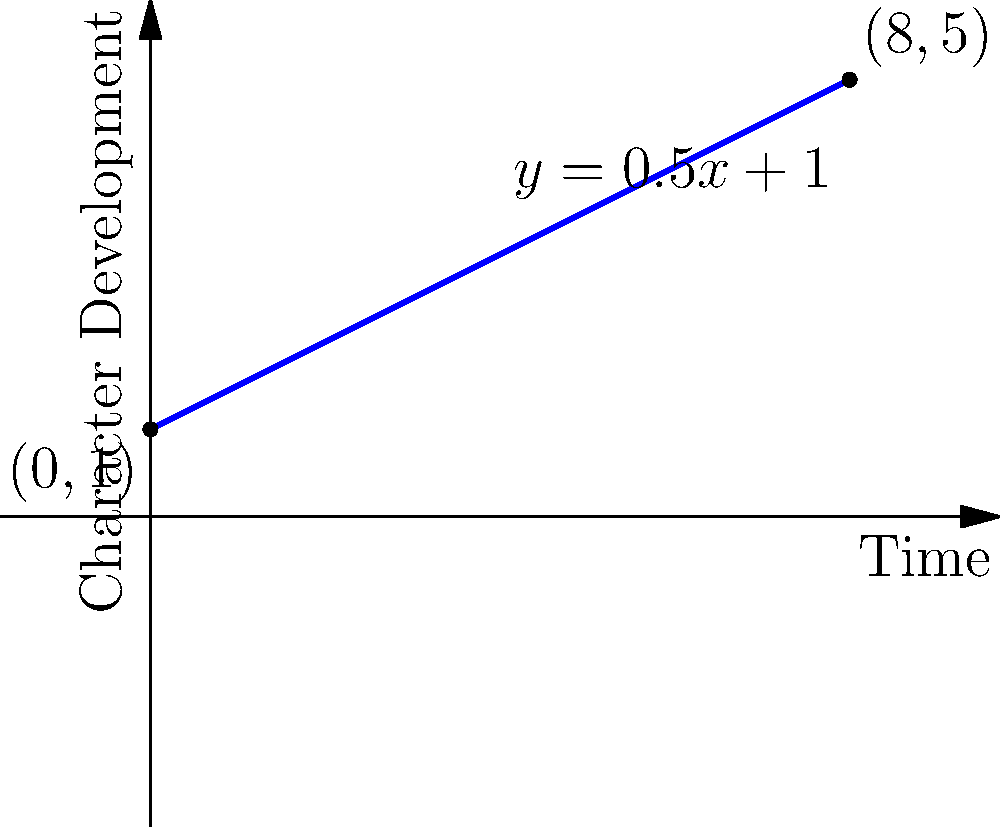In creative writing, character development can be visualized using the slope-intercept form of a line. Consider the graph above representing a character's growth over time in a narrative. The line is described by the equation $y = 0.5x + 1$, where $x$ represents time and $y$ represents the level of character development. What does the slope (0.5) indicate about the character's progression, and how might this inform the pacing of the narrative? To analyze the character development trajectory using the slope-intercept form:

1. Identify the equation: $y = 0.5x + 1$

2. Break down the components:
   - Slope (m) = 0.5
   - y-intercept (b) = 1

3. Interpret the slope (0.5):
   - The slope represents the rate of change in character development over time.
   - A positive slope indicates growth or positive development.
   - The value 0.5 suggests a moderate, steady rate of growth.

4. Analyze the y-intercept (1):
   - This represents the character's initial development level at the start of the narrative.

5. Consider the implications for narrative pacing:
   - The moderate slope implies a gradual, consistent character arc.
   - This suggests a narrative that allows for steady character growth rather than sudden transformations.
   - The pacing should reflect this gradual development, potentially focusing on small, incremental changes in the character over time.

6. Evaluate the end point (8,5):
   - After 8 units of time, the character has reached a development level of 5.
   - This shows significant growth from the starting point (0,1) but achieved through consistent progression.

7. Narrative structure implications:
   - The linear nature of the growth suggests a narrative that might benefit from a series of challenges or experiences that build upon each other.
   - The writer could structure the plot to mirror this steady progression, potentially dividing the narrative into distinct phases of growth.
Answer: The slope (0.5) indicates a moderate, steady rate of character growth, suggesting a narrative pacing that focuses on gradual, consistent development rather than abrupt changes. 